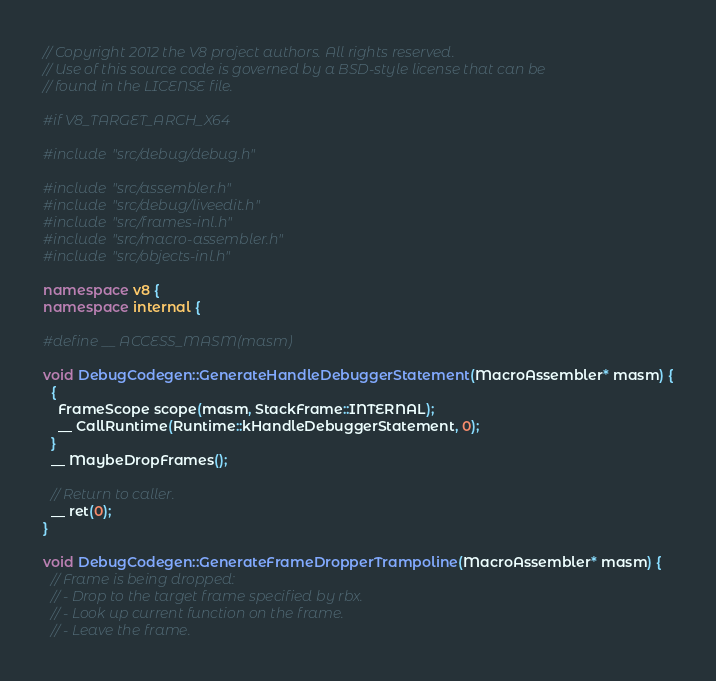<code> <loc_0><loc_0><loc_500><loc_500><_C++_>// Copyright 2012 the V8 project authors. All rights reserved.
// Use of this source code is governed by a BSD-style license that can be
// found in the LICENSE file.

#if V8_TARGET_ARCH_X64

#include "src/debug/debug.h"

#include "src/assembler.h"
#include "src/debug/liveedit.h"
#include "src/frames-inl.h"
#include "src/macro-assembler.h"
#include "src/objects-inl.h"

namespace v8 {
namespace internal {

#define __ ACCESS_MASM(masm)

void DebugCodegen::GenerateHandleDebuggerStatement(MacroAssembler* masm) {
  {
    FrameScope scope(masm, StackFrame::INTERNAL);
    __ CallRuntime(Runtime::kHandleDebuggerStatement, 0);
  }
  __ MaybeDropFrames();

  // Return to caller.
  __ ret(0);
}

void DebugCodegen::GenerateFrameDropperTrampoline(MacroAssembler* masm) {
  // Frame is being dropped:
  // - Drop to the target frame specified by rbx.
  // - Look up current function on the frame.
  // - Leave the frame.</code> 